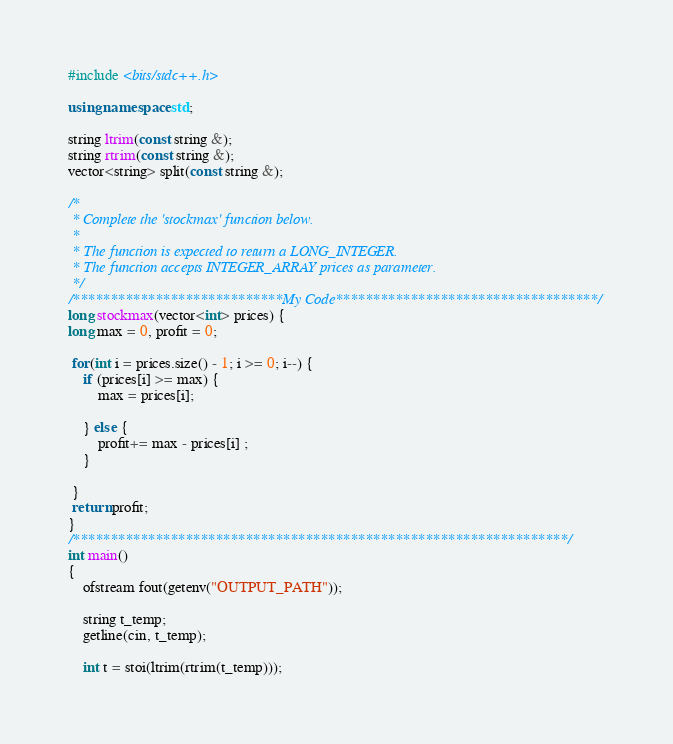Convert code to text. <code><loc_0><loc_0><loc_500><loc_500><_C++_>#include <bits/stdc++.h>

using namespace std;

string ltrim(const string &);
string rtrim(const string &);
vector<string> split(const string &);

/*
 * Complete the 'stockmax' function below.
 *
 * The function is expected to return a LONG_INTEGER.
 * The function accepts INTEGER_ARRAY prices as parameter.
 */
/****************************My Code***********************************/
long stockmax(vector<int> prices) {
long max = 0, profit = 0;

 for(int i = prices.size() - 1; i >= 0; i--) {
    if (prices[i] >= max) {
        max = prices[i];
        
    } else {
        profit+= max - prices[i] ; 
    }

 }
 return profit;
}
/******************************************************************/
int main()
{
    ofstream fout(getenv("OUTPUT_PATH"));

    string t_temp;
    getline(cin, t_temp);

    int t = stoi(ltrim(rtrim(t_temp)));
</code> 